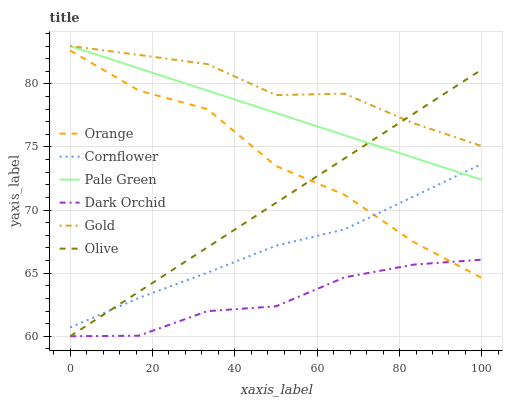Does Dark Orchid have the minimum area under the curve?
Answer yes or no. Yes. Does Gold have the maximum area under the curve?
Answer yes or no. Yes. Does Gold have the minimum area under the curve?
Answer yes or no. No. Does Dark Orchid have the maximum area under the curve?
Answer yes or no. No. Is Olive the smoothest?
Answer yes or no. Yes. Is Orange the roughest?
Answer yes or no. Yes. Is Gold the smoothest?
Answer yes or no. No. Is Gold the roughest?
Answer yes or no. No. Does Dark Orchid have the lowest value?
Answer yes or no. Yes. Does Gold have the lowest value?
Answer yes or no. No. Does Pale Green have the highest value?
Answer yes or no. Yes. Does Dark Orchid have the highest value?
Answer yes or no. No. Is Dark Orchid less than Gold?
Answer yes or no. Yes. Is Cornflower greater than Dark Orchid?
Answer yes or no. Yes. Does Dark Orchid intersect Orange?
Answer yes or no. Yes. Is Dark Orchid less than Orange?
Answer yes or no. No. Is Dark Orchid greater than Orange?
Answer yes or no. No. Does Dark Orchid intersect Gold?
Answer yes or no. No. 